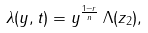<formula> <loc_0><loc_0><loc_500><loc_500>\lambda ( y , t ) = y ^ { \frac { 1 - r } { n } } \, \Lambda ( z _ { 2 } ) ,</formula> 